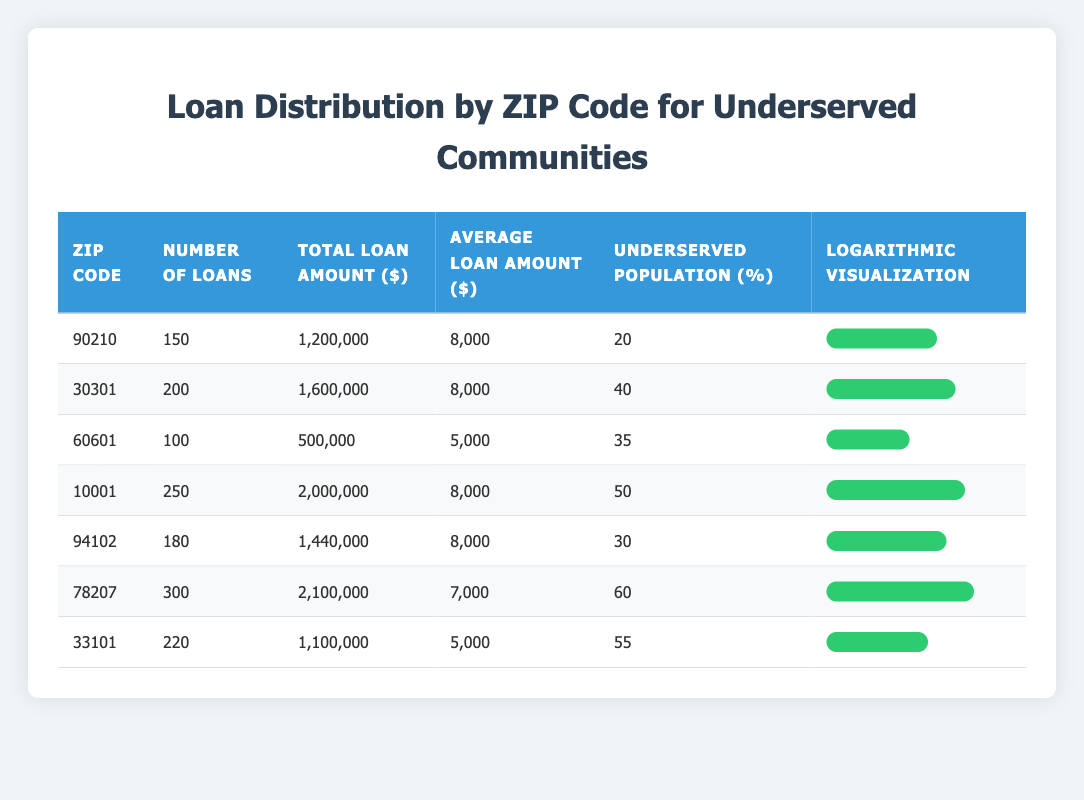What is the total loan amount for ZIP code 10001? The total loan amount for ZIP code 10001, according to the table, is explicitly stated as 2,000,000.
Answer: 2,000,000 How many loans were distributed in ZIP code 78207? The table indicates that there were 300 loans distributed in ZIP code 78207.
Answer: 300 Which ZIP code has the highest percentage of underserved population? By examining the "Underserved Population (%)" column, I can see that ZIP code 78207 has the highest percentage at 60%.
Answer: 78207 What is the average loan amount for loans distributed in ZIP code 33101? The average loan amount for ZIP code 33101 is provided in the table as 5,000.
Answer: 5,000 What is the total number of loans across all ZIP codes listed? To find the total number of loans, I sum the "Number of Loans" column: 150 + 200 + 100 + 250 + 180 + 300 + 220 = 1,400.
Answer: 1,400 Is the average loan amount for ZIP code 60601 less than 6,000? The average loan amount for ZIP code 60601 is 5,000 which is less than 6,000, therefore the statement is true.
Answer: Yes Which ZIP code has the lowest total loan amount? By checking the "Total Loan Amount ($)" column, ZIP code 60601 has the lowest amount at 500,000.
Answer: 60601 How many loans were issued in ZIP code 30301 compared to ZIP code 94102? ZIP code 30301 has 200 loans while ZIP code 94102 has 180 loans. The difference is 200 - 180 = 20, so 20 more loans were issued in 30301.
Answer: 20 Is it true that ZIP code 10001 has a higher number of loans distributed than ZIP code 33101? The table shows that ZIP code 10001 has 250 loans while ZIP code 33101 has 220 loans, confirming that 10001 has a higher number of loans.
Answer: Yes 